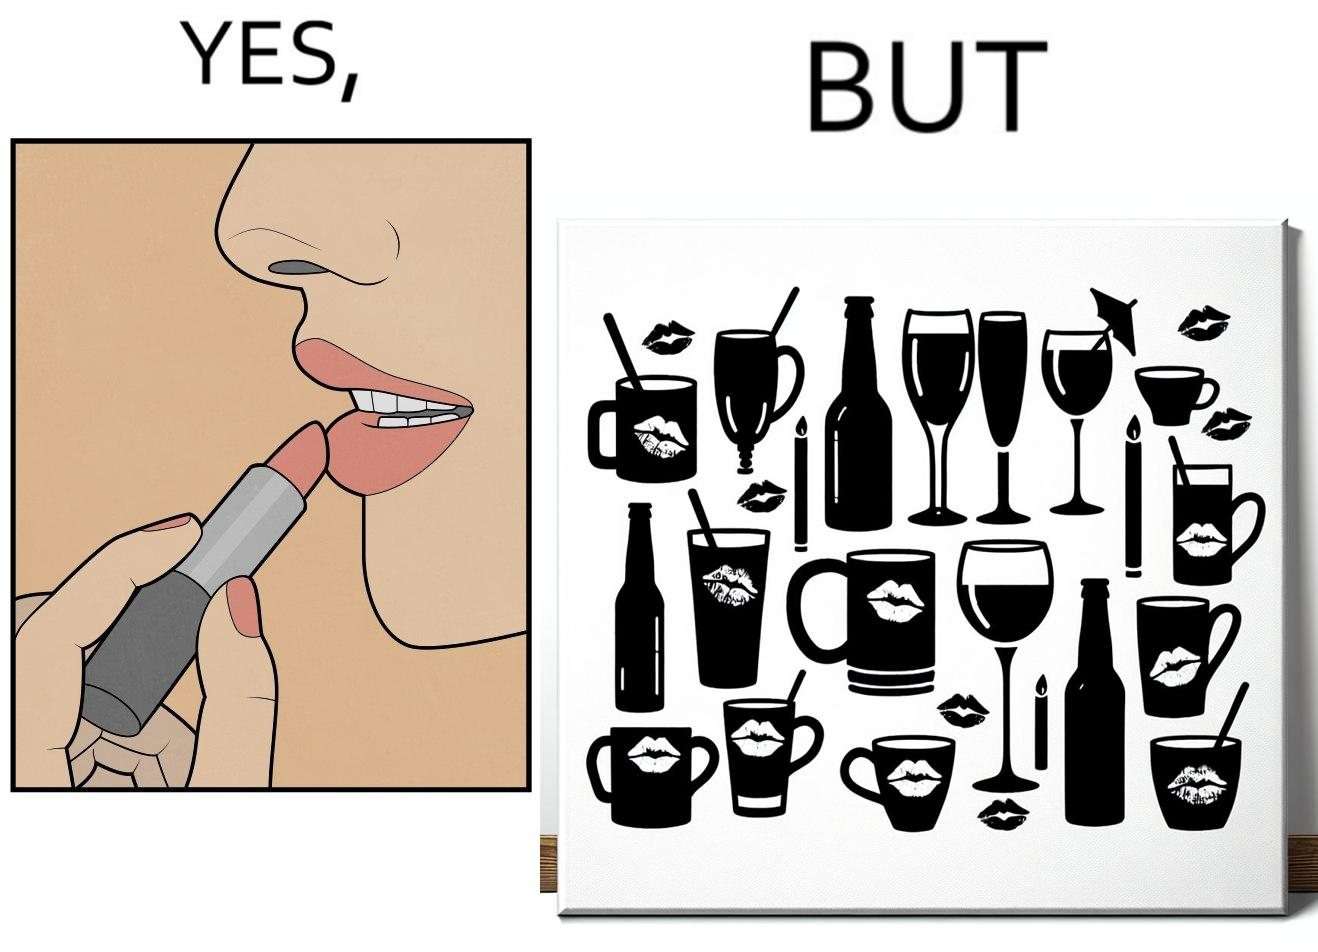Why is this image considered satirical? The image is ironic, because the left image suggest that a person applies lipsticks on their lips to make their lips look attractive or to keep them hydrated but on the contrary it gets sticked to the glasses or mugs and gets wasted 